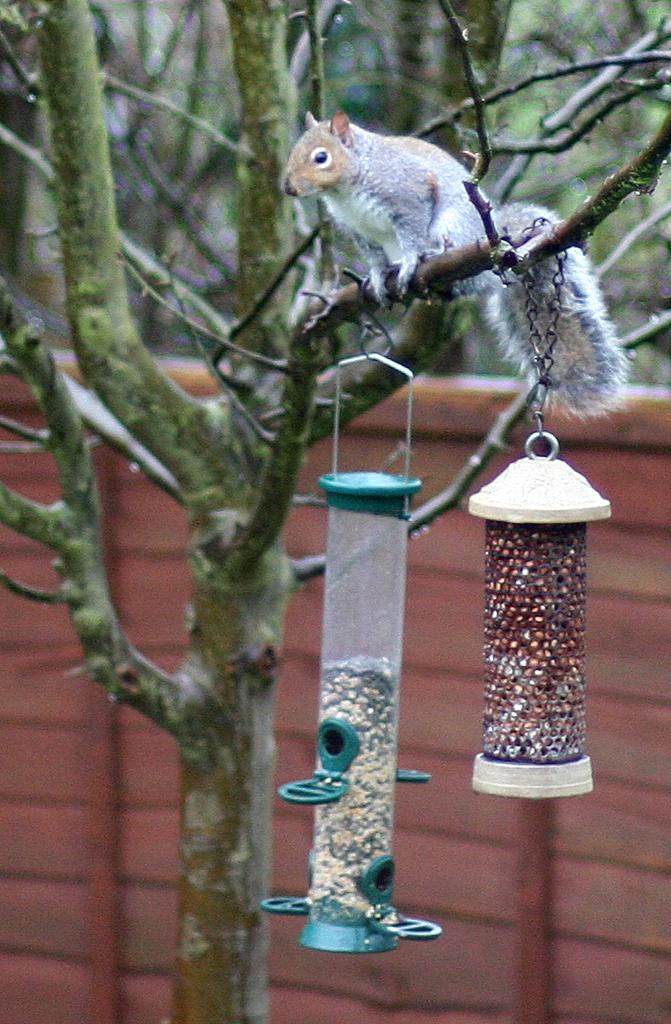What type of animal is present in the image? There is a squirrel in the image. What is the squirrel interacting with in the image? The squirrel is interacting with a tree that has two objects hanging from it. What can be seen in the background of the image? There is a wall visible in the background of the image. How many brothers does the squirrel have in the image? There is no information about the squirrel's brothers in the image. What shape is the squirrel in the image? The squirrel is not a shape; it is a living animal. 